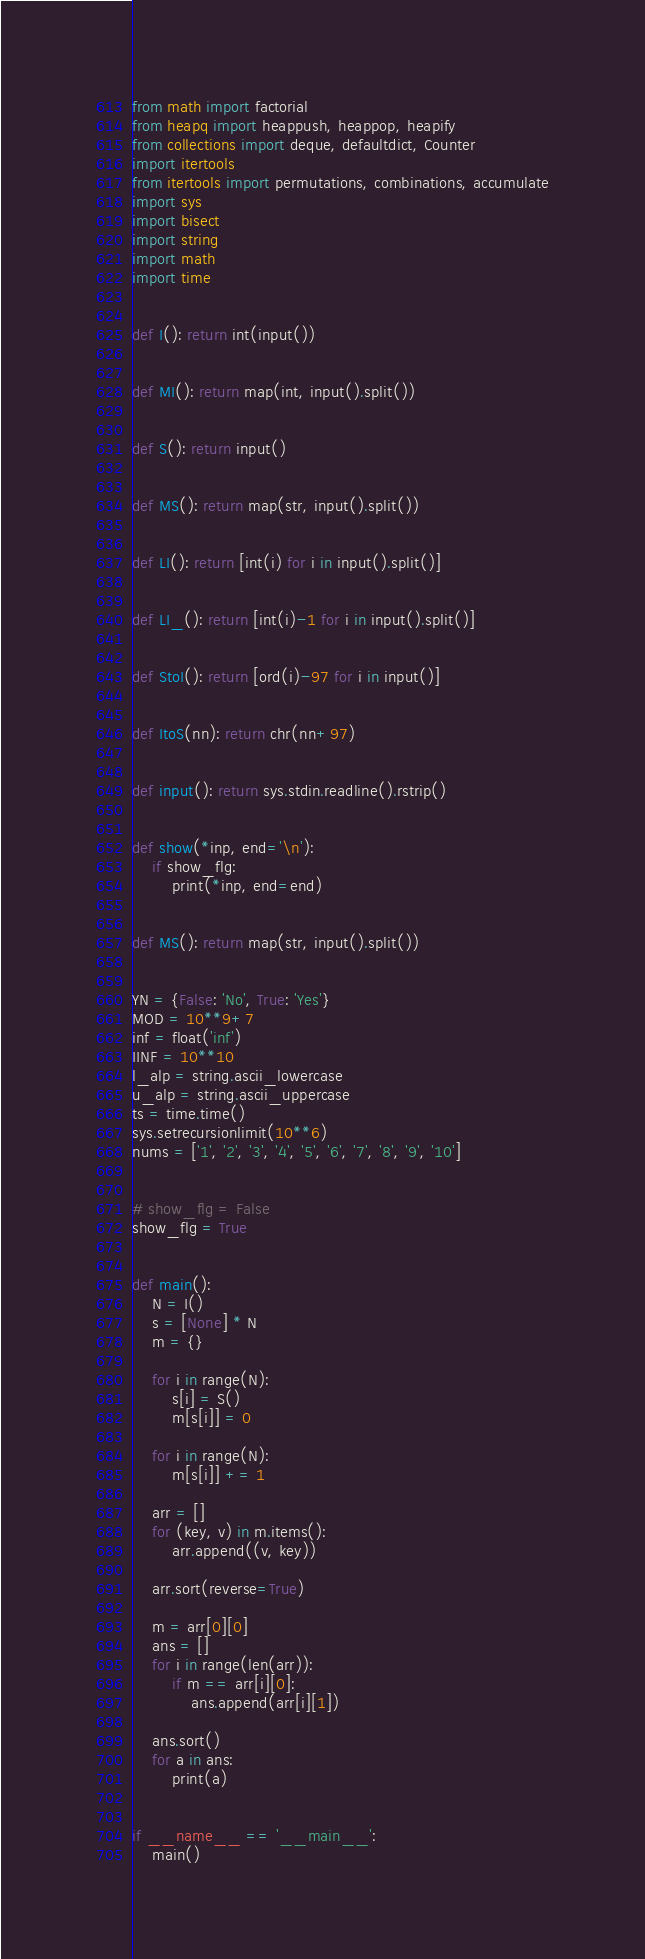Convert code to text. <code><loc_0><loc_0><loc_500><loc_500><_Python_>from math import factorial
from heapq import heappush, heappop, heapify
from collections import deque, defaultdict, Counter
import itertools
from itertools import permutations, combinations, accumulate
import sys
import bisect
import string
import math
import time


def I(): return int(input())


def MI(): return map(int, input().split())


def S(): return input()


def MS(): return map(str, input().split())


def LI(): return [int(i) for i in input().split()]


def LI_(): return [int(i)-1 for i in input().split()]


def StoI(): return [ord(i)-97 for i in input()]


def ItoS(nn): return chr(nn+97)


def input(): return sys.stdin.readline().rstrip()


def show(*inp, end='\n'):
    if show_flg:
        print(*inp, end=end)


def MS(): return map(str, input().split())


YN = {False: 'No', True: 'Yes'}
MOD = 10**9+7
inf = float('inf')
IINF = 10**10
l_alp = string.ascii_lowercase
u_alp = string.ascii_uppercase
ts = time.time()
sys.setrecursionlimit(10**6)
nums = ['1', '2', '3', '4', '5', '6', '7', '8', '9', '10']


# show_flg = False
show_flg = True


def main():
    N = I()
    s = [None] * N
    m = {}

    for i in range(N):
        s[i] = S()
        m[s[i]] = 0

    for i in range(N):
        m[s[i]] += 1

    arr = []
    for (key, v) in m.items():
        arr.append((v, key))

    arr.sort(reverse=True)

    m = arr[0][0]
    ans = []
    for i in range(len(arr)):
        if m == arr[i][0]:
            ans.append(arr[i][1])

    ans.sort()
    for a in ans:
        print(a)


if __name__ == '__main__':
    main()
</code> 